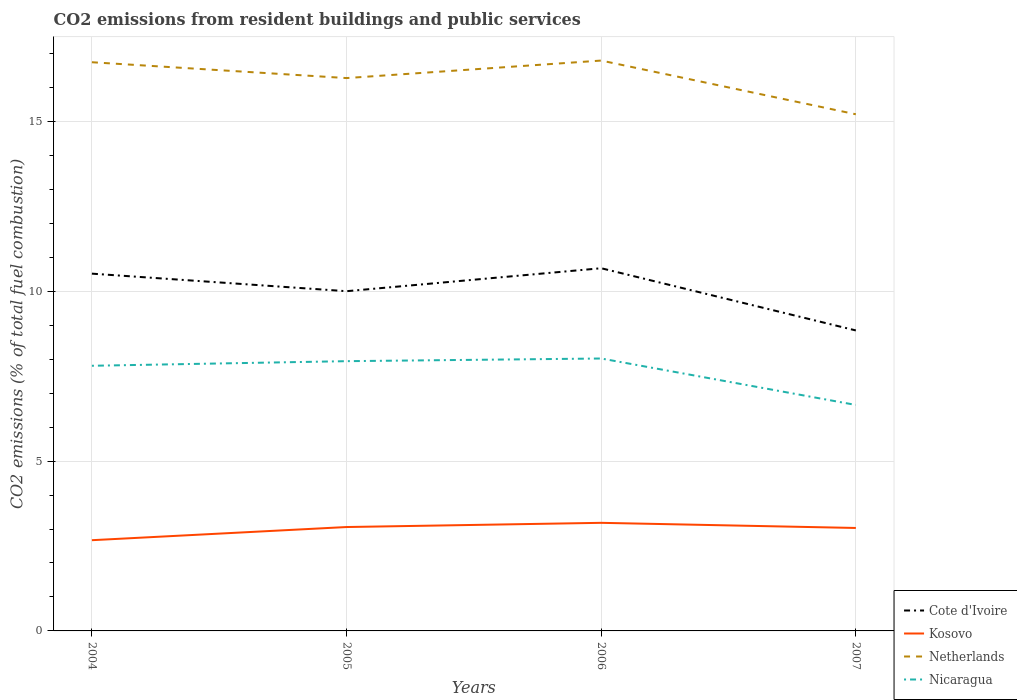Is the number of lines equal to the number of legend labels?
Provide a succinct answer. Yes. Across all years, what is the maximum total CO2 emitted in Kosovo?
Your answer should be very brief. 2.67. What is the total total CO2 emitted in Nicaragua in the graph?
Offer a terse response. -0.14. What is the difference between the highest and the second highest total CO2 emitted in Nicaragua?
Make the answer very short. 1.37. Is the total CO2 emitted in Netherlands strictly greater than the total CO2 emitted in Cote d'Ivoire over the years?
Your answer should be very brief. No. How many lines are there?
Ensure brevity in your answer.  4. What is the difference between two consecutive major ticks on the Y-axis?
Offer a very short reply. 5. Are the values on the major ticks of Y-axis written in scientific E-notation?
Your answer should be very brief. No. How are the legend labels stacked?
Make the answer very short. Vertical. What is the title of the graph?
Offer a very short reply. CO2 emissions from resident buildings and public services. Does "Madagascar" appear as one of the legend labels in the graph?
Offer a terse response. No. What is the label or title of the X-axis?
Your answer should be very brief. Years. What is the label or title of the Y-axis?
Make the answer very short. CO2 emissions (% of total fuel combustion). What is the CO2 emissions (% of total fuel combustion) in Cote d'Ivoire in 2004?
Ensure brevity in your answer.  10.52. What is the CO2 emissions (% of total fuel combustion) in Kosovo in 2004?
Your answer should be very brief. 2.67. What is the CO2 emissions (% of total fuel combustion) of Netherlands in 2004?
Your answer should be very brief. 16.74. What is the CO2 emissions (% of total fuel combustion) in Nicaragua in 2004?
Ensure brevity in your answer.  7.8. What is the CO2 emissions (% of total fuel combustion) in Cote d'Ivoire in 2005?
Offer a terse response. 10. What is the CO2 emissions (% of total fuel combustion) in Kosovo in 2005?
Provide a short and direct response. 3.06. What is the CO2 emissions (% of total fuel combustion) of Netherlands in 2005?
Your response must be concise. 16.27. What is the CO2 emissions (% of total fuel combustion) of Nicaragua in 2005?
Give a very brief answer. 7.94. What is the CO2 emissions (% of total fuel combustion) in Cote d'Ivoire in 2006?
Offer a very short reply. 10.68. What is the CO2 emissions (% of total fuel combustion) of Kosovo in 2006?
Give a very brief answer. 3.18. What is the CO2 emissions (% of total fuel combustion) in Netherlands in 2006?
Provide a succinct answer. 16.79. What is the CO2 emissions (% of total fuel combustion) of Nicaragua in 2006?
Offer a terse response. 8.02. What is the CO2 emissions (% of total fuel combustion) of Cote d'Ivoire in 2007?
Your answer should be compact. 8.84. What is the CO2 emissions (% of total fuel combustion) in Kosovo in 2007?
Make the answer very short. 3.03. What is the CO2 emissions (% of total fuel combustion) in Netherlands in 2007?
Provide a short and direct response. 15.21. What is the CO2 emissions (% of total fuel combustion) in Nicaragua in 2007?
Give a very brief answer. 6.65. Across all years, what is the maximum CO2 emissions (% of total fuel combustion) in Cote d'Ivoire?
Offer a very short reply. 10.68. Across all years, what is the maximum CO2 emissions (% of total fuel combustion) of Kosovo?
Give a very brief answer. 3.18. Across all years, what is the maximum CO2 emissions (% of total fuel combustion) in Netherlands?
Offer a very short reply. 16.79. Across all years, what is the maximum CO2 emissions (% of total fuel combustion) of Nicaragua?
Ensure brevity in your answer.  8.02. Across all years, what is the minimum CO2 emissions (% of total fuel combustion) of Cote d'Ivoire?
Provide a succinct answer. 8.84. Across all years, what is the minimum CO2 emissions (% of total fuel combustion) of Kosovo?
Your response must be concise. 2.67. Across all years, what is the minimum CO2 emissions (% of total fuel combustion) in Netherlands?
Offer a very short reply. 15.21. Across all years, what is the minimum CO2 emissions (% of total fuel combustion) of Nicaragua?
Offer a very short reply. 6.65. What is the total CO2 emissions (% of total fuel combustion) in Cote d'Ivoire in the graph?
Your answer should be very brief. 40.04. What is the total CO2 emissions (% of total fuel combustion) in Kosovo in the graph?
Offer a terse response. 11.94. What is the total CO2 emissions (% of total fuel combustion) in Netherlands in the graph?
Offer a terse response. 65.01. What is the total CO2 emissions (% of total fuel combustion) of Nicaragua in the graph?
Keep it short and to the point. 30.42. What is the difference between the CO2 emissions (% of total fuel combustion) of Cote d'Ivoire in 2004 and that in 2005?
Keep it short and to the point. 0.52. What is the difference between the CO2 emissions (% of total fuel combustion) in Kosovo in 2004 and that in 2005?
Give a very brief answer. -0.39. What is the difference between the CO2 emissions (% of total fuel combustion) in Netherlands in 2004 and that in 2005?
Make the answer very short. 0.47. What is the difference between the CO2 emissions (% of total fuel combustion) in Nicaragua in 2004 and that in 2005?
Ensure brevity in your answer.  -0.14. What is the difference between the CO2 emissions (% of total fuel combustion) in Cote d'Ivoire in 2004 and that in 2006?
Make the answer very short. -0.16. What is the difference between the CO2 emissions (% of total fuel combustion) of Kosovo in 2004 and that in 2006?
Provide a succinct answer. -0.51. What is the difference between the CO2 emissions (% of total fuel combustion) of Netherlands in 2004 and that in 2006?
Your response must be concise. -0.05. What is the difference between the CO2 emissions (% of total fuel combustion) in Nicaragua in 2004 and that in 2006?
Your answer should be compact. -0.21. What is the difference between the CO2 emissions (% of total fuel combustion) in Cote d'Ivoire in 2004 and that in 2007?
Offer a terse response. 1.67. What is the difference between the CO2 emissions (% of total fuel combustion) of Kosovo in 2004 and that in 2007?
Provide a short and direct response. -0.36. What is the difference between the CO2 emissions (% of total fuel combustion) of Netherlands in 2004 and that in 2007?
Provide a succinct answer. 1.53. What is the difference between the CO2 emissions (% of total fuel combustion) of Nicaragua in 2004 and that in 2007?
Provide a short and direct response. 1.15. What is the difference between the CO2 emissions (% of total fuel combustion) of Cote d'Ivoire in 2005 and that in 2006?
Offer a very short reply. -0.68. What is the difference between the CO2 emissions (% of total fuel combustion) in Kosovo in 2005 and that in 2006?
Give a very brief answer. -0.12. What is the difference between the CO2 emissions (% of total fuel combustion) in Netherlands in 2005 and that in 2006?
Provide a succinct answer. -0.52. What is the difference between the CO2 emissions (% of total fuel combustion) in Nicaragua in 2005 and that in 2006?
Keep it short and to the point. -0.08. What is the difference between the CO2 emissions (% of total fuel combustion) of Cote d'Ivoire in 2005 and that in 2007?
Offer a very short reply. 1.16. What is the difference between the CO2 emissions (% of total fuel combustion) in Kosovo in 2005 and that in 2007?
Keep it short and to the point. 0.03. What is the difference between the CO2 emissions (% of total fuel combustion) in Netherlands in 2005 and that in 2007?
Make the answer very short. 1.07. What is the difference between the CO2 emissions (% of total fuel combustion) of Nicaragua in 2005 and that in 2007?
Your answer should be compact. 1.29. What is the difference between the CO2 emissions (% of total fuel combustion) of Cote d'Ivoire in 2006 and that in 2007?
Offer a terse response. 1.83. What is the difference between the CO2 emissions (% of total fuel combustion) in Kosovo in 2006 and that in 2007?
Offer a very short reply. 0.15. What is the difference between the CO2 emissions (% of total fuel combustion) in Netherlands in 2006 and that in 2007?
Ensure brevity in your answer.  1.58. What is the difference between the CO2 emissions (% of total fuel combustion) of Nicaragua in 2006 and that in 2007?
Make the answer very short. 1.37. What is the difference between the CO2 emissions (% of total fuel combustion) in Cote d'Ivoire in 2004 and the CO2 emissions (% of total fuel combustion) in Kosovo in 2005?
Keep it short and to the point. 7.46. What is the difference between the CO2 emissions (% of total fuel combustion) in Cote d'Ivoire in 2004 and the CO2 emissions (% of total fuel combustion) in Netherlands in 2005?
Your answer should be compact. -5.76. What is the difference between the CO2 emissions (% of total fuel combustion) of Cote d'Ivoire in 2004 and the CO2 emissions (% of total fuel combustion) of Nicaragua in 2005?
Your answer should be very brief. 2.58. What is the difference between the CO2 emissions (% of total fuel combustion) of Kosovo in 2004 and the CO2 emissions (% of total fuel combustion) of Netherlands in 2005?
Ensure brevity in your answer.  -13.6. What is the difference between the CO2 emissions (% of total fuel combustion) of Kosovo in 2004 and the CO2 emissions (% of total fuel combustion) of Nicaragua in 2005?
Provide a short and direct response. -5.27. What is the difference between the CO2 emissions (% of total fuel combustion) in Netherlands in 2004 and the CO2 emissions (% of total fuel combustion) in Nicaragua in 2005?
Your answer should be compact. 8.8. What is the difference between the CO2 emissions (% of total fuel combustion) of Cote d'Ivoire in 2004 and the CO2 emissions (% of total fuel combustion) of Kosovo in 2006?
Ensure brevity in your answer.  7.33. What is the difference between the CO2 emissions (% of total fuel combustion) in Cote d'Ivoire in 2004 and the CO2 emissions (% of total fuel combustion) in Netherlands in 2006?
Make the answer very short. -6.27. What is the difference between the CO2 emissions (% of total fuel combustion) of Cote d'Ivoire in 2004 and the CO2 emissions (% of total fuel combustion) of Nicaragua in 2006?
Give a very brief answer. 2.5. What is the difference between the CO2 emissions (% of total fuel combustion) in Kosovo in 2004 and the CO2 emissions (% of total fuel combustion) in Netherlands in 2006?
Ensure brevity in your answer.  -14.12. What is the difference between the CO2 emissions (% of total fuel combustion) of Kosovo in 2004 and the CO2 emissions (% of total fuel combustion) of Nicaragua in 2006?
Offer a terse response. -5.35. What is the difference between the CO2 emissions (% of total fuel combustion) of Netherlands in 2004 and the CO2 emissions (% of total fuel combustion) of Nicaragua in 2006?
Offer a very short reply. 8.72. What is the difference between the CO2 emissions (% of total fuel combustion) of Cote d'Ivoire in 2004 and the CO2 emissions (% of total fuel combustion) of Kosovo in 2007?
Offer a terse response. 7.49. What is the difference between the CO2 emissions (% of total fuel combustion) in Cote d'Ivoire in 2004 and the CO2 emissions (% of total fuel combustion) in Netherlands in 2007?
Give a very brief answer. -4.69. What is the difference between the CO2 emissions (% of total fuel combustion) in Cote d'Ivoire in 2004 and the CO2 emissions (% of total fuel combustion) in Nicaragua in 2007?
Your answer should be compact. 3.87. What is the difference between the CO2 emissions (% of total fuel combustion) in Kosovo in 2004 and the CO2 emissions (% of total fuel combustion) in Netherlands in 2007?
Provide a succinct answer. -12.54. What is the difference between the CO2 emissions (% of total fuel combustion) in Kosovo in 2004 and the CO2 emissions (% of total fuel combustion) in Nicaragua in 2007?
Offer a very short reply. -3.98. What is the difference between the CO2 emissions (% of total fuel combustion) in Netherlands in 2004 and the CO2 emissions (% of total fuel combustion) in Nicaragua in 2007?
Ensure brevity in your answer.  10.09. What is the difference between the CO2 emissions (% of total fuel combustion) of Cote d'Ivoire in 2005 and the CO2 emissions (% of total fuel combustion) of Kosovo in 2006?
Offer a terse response. 6.82. What is the difference between the CO2 emissions (% of total fuel combustion) of Cote d'Ivoire in 2005 and the CO2 emissions (% of total fuel combustion) of Netherlands in 2006?
Your answer should be compact. -6.79. What is the difference between the CO2 emissions (% of total fuel combustion) of Cote d'Ivoire in 2005 and the CO2 emissions (% of total fuel combustion) of Nicaragua in 2006?
Offer a very short reply. 1.98. What is the difference between the CO2 emissions (% of total fuel combustion) of Kosovo in 2005 and the CO2 emissions (% of total fuel combustion) of Netherlands in 2006?
Make the answer very short. -13.73. What is the difference between the CO2 emissions (% of total fuel combustion) in Kosovo in 2005 and the CO2 emissions (% of total fuel combustion) in Nicaragua in 2006?
Make the answer very short. -4.96. What is the difference between the CO2 emissions (% of total fuel combustion) of Netherlands in 2005 and the CO2 emissions (% of total fuel combustion) of Nicaragua in 2006?
Your response must be concise. 8.25. What is the difference between the CO2 emissions (% of total fuel combustion) of Cote d'Ivoire in 2005 and the CO2 emissions (% of total fuel combustion) of Kosovo in 2007?
Provide a succinct answer. 6.97. What is the difference between the CO2 emissions (% of total fuel combustion) of Cote d'Ivoire in 2005 and the CO2 emissions (% of total fuel combustion) of Netherlands in 2007?
Offer a terse response. -5.21. What is the difference between the CO2 emissions (% of total fuel combustion) of Cote d'Ivoire in 2005 and the CO2 emissions (% of total fuel combustion) of Nicaragua in 2007?
Offer a terse response. 3.35. What is the difference between the CO2 emissions (% of total fuel combustion) of Kosovo in 2005 and the CO2 emissions (% of total fuel combustion) of Netherlands in 2007?
Give a very brief answer. -12.15. What is the difference between the CO2 emissions (% of total fuel combustion) of Kosovo in 2005 and the CO2 emissions (% of total fuel combustion) of Nicaragua in 2007?
Your answer should be very brief. -3.59. What is the difference between the CO2 emissions (% of total fuel combustion) of Netherlands in 2005 and the CO2 emissions (% of total fuel combustion) of Nicaragua in 2007?
Your answer should be compact. 9.62. What is the difference between the CO2 emissions (% of total fuel combustion) in Cote d'Ivoire in 2006 and the CO2 emissions (% of total fuel combustion) in Kosovo in 2007?
Your answer should be compact. 7.65. What is the difference between the CO2 emissions (% of total fuel combustion) in Cote d'Ivoire in 2006 and the CO2 emissions (% of total fuel combustion) in Netherlands in 2007?
Provide a short and direct response. -4.53. What is the difference between the CO2 emissions (% of total fuel combustion) in Cote d'Ivoire in 2006 and the CO2 emissions (% of total fuel combustion) in Nicaragua in 2007?
Make the answer very short. 4.02. What is the difference between the CO2 emissions (% of total fuel combustion) of Kosovo in 2006 and the CO2 emissions (% of total fuel combustion) of Netherlands in 2007?
Your answer should be compact. -12.03. What is the difference between the CO2 emissions (% of total fuel combustion) in Kosovo in 2006 and the CO2 emissions (% of total fuel combustion) in Nicaragua in 2007?
Ensure brevity in your answer.  -3.47. What is the difference between the CO2 emissions (% of total fuel combustion) of Netherlands in 2006 and the CO2 emissions (% of total fuel combustion) of Nicaragua in 2007?
Make the answer very short. 10.14. What is the average CO2 emissions (% of total fuel combustion) of Cote d'Ivoire per year?
Make the answer very short. 10.01. What is the average CO2 emissions (% of total fuel combustion) in Kosovo per year?
Ensure brevity in your answer.  2.99. What is the average CO2 emissions (% of total fuel combustion) in Netherlands per year?
Your response must be concise. 16.25. What is the average CO2 emissions (% of total fuel combustion) in Nicaragua per year?
Make the answer very short. 7.6. In the year 2004, what is the difference between the CO2 emissions (% of total fuel combustion) in Cote d'Ivoire and CO2 emissions (% of total fuel combustion) in Kosovo?
Provide a succinct answer. 7.85. In the year 2004, what is the difference between the CO2 emissions (% of total fuel combustion) in Cote d'Ivoire and CO2 emissions (% of total fuel combustion) in Netherlands?
Provide a short and direct response. -6.22. In the year 2004, what is the difference between the CO2 emissions (% of total fuel combustion) in Cote d'Ivoire and CO2 emissions (% of total fuel combustion) in Nicaragua?
Keep it short and to the point. 2.71. In the year 2004, what is the difference between the CO2 emissions (% of total fuel combustion) in Kosovo and CO2 emissions (% of total fuel combustion) in Netherlands?
Your answer should be compact. -14.07. In the year 2004, what is the difference between the CO2 emissions (% of total fuel combustion) of Kosovo and CO2 emissions (% of total fuel combustion) of Nicaragua?
Make the answer very short. -5.13. In the year 2004, what is the difference between the CO2 emissions (% of total fuel combustion) of Netherlands and CO2 emissions (% of total fuel combustion) of Nicaragua?
Provide a succinct answer. 8.93. In the year 2005, what is the difference between the CO2 emissions (% of total fuel combustion) in Cote d'Ivoire and CO2 emissions (% of total fuel combustion) in Kosovo?
Your answer should be compact. 6.94. In the year 2005, what is the difference between the CO2 emissions (% of total fuel combustion) in Cote d'Ivoire and CO2 emissions (% of total fuel combustion) in Netherlands?
Your answer should be compact. -6.27. In the year 2005, what is the difference between the CO2 emissions (% of total fuel combustion) of Cote d'Ivoire and CO2 emissions (% of total fuel combustion) of Nicaragua?
Provide a succinct answer. 2.06. In the year 2005, what is the difference between the CO2 emissions (% of total fuel combustion) of Kosovo and CO2 emissions (% of total fuel combustion) of Netherlands?
Your answer should be compact. -13.22. In the year 2005, what is the difference between the CO2 emissions (% of total fuel combustion) in Kosovo and CO2 emissions (% of total fuel combustion) in Nicaragua?
Provide a succinct answer. -4.88. In the year 2005, what is the difference between the CO2 emissions (% of total fuel combustion) of Netherlands and CO2 emissions (% of total fuel combustion) of Nicaragua?
Provide a succinct answer. 8.33. In the year 2006, what is the difference between the CO2 emissions (% of total fuel combustion) of Cote d'Ivoire and CO2 emissions (% of total fuel combustion) of Kosovo?
Your response must be concise. 7.49. In the year 2006, what is the difference between the CO2 emissions (% of total fuel combustion) in Cote d'Ivoire and CO2 emissions (% of total fuel combustion) in Netherlands?
Your answer should be compact. -6.11. In the year 2006, what is the difference between the CO2 emissions (% of total fuel combustion) in Cote d'Ivoire and CO2 emissions (% of total fuel combustion) in Nicaragua?
Offer a very short reply. 2.66. In the year 2006, what is the difference between the CO2 emissions (% of total fuel combustion) of Kosovo and CO2 emissions (% of total fuel combustion) of Netherlands?
Make the answer very short. -13.61. In the year 2006, what is the difference between the CO2 emissions (% of total fuel combustion) of Kosovo and CO2 emissions (% of total fuel combustion) of Nicaragua?
Offer a very short reply. -4.84. In the year 2006, what is the difference between the CO2 emissions (% of total fuel combustion) in Netherlands and CO2 emissions (% of total fuel combustion) in Nicaragua?
Give a very brief answer. 8.77. In the year 2007, what is the difference between the CO2 emissions (% of total fuel combustion) of Cote d'Ivoire and CO2 emissions (% of total fuel combustion) of Kosovo?
Make the answer very short. 5.81. In the year 2007, what is the difference between the CO2 emissions (% of total fuel combustion) in Cote d'Ivoire and CO2 emissions (% of total fuel combustion) in Netherlands?
Your answer should be very brief. -6.36. In the year 2007, what is the difference between the CO2 emissions (% of total fuel combustion) in Cote d'Ivoire and CO2 emissions (% of total fuel combustion) in Nicaragua?
Make the answer very short. 2.19. In the year 2007, what is the difference between the CO2 emissions (% of total fuel combustion) in Kosovo and CO2 emissions (% of total fuel combustion) in Netherlands?
Keep it short and to the point. -12.18. In the year 2007, what is the difference between the CO2 emissions (% of total fuel combustion) in Kosovo and CO2 emissions (% of total fuel combustion) in Nicaragua?
Your answer should be compact. -3.62. In the year 2007, what is the difference between the CO2 emissions (% of total fuel combustion) in Netherlands and CO2 emissions (% of total fuel combustion) in Nicaragua?
Give a very brief answer. 8.56. What is the ratio of the CO2 emissions (% of total fuel combustion) in Cote d'Ivoire in 2004 to that in 2005?
Offer a very short reply. 1.05. What is the ratio of the CO2 emissions (% of total fuel combustion) of Kosovo in 2004 to that in 2005?
Your response must be concise. 0.87. What is the ratio of the CO2 emissions (% of total fuel combustion) in Netherlands in 2004 to that in 2005?
Offer a very short reply. 1.03. What is the ratio of the CO2 emissions (% of total fuel combustion) in Nicaragua in 2004 to that in 2005?
Your response must be concise. 0.98. What is the ratio of the CO2 emissions (% of total fuel combustion) of Cote d'Ivoire in 2004 to that in 2006?
Offer a terse response. 0.99. What is the ratio of the CO2 emissions (% of total fuel combustion) of Kosovo in 2004 to that in 2006?
Provide a short and direct response. 0.84. What is the ratio of the CO2 emissions (% of total fuel combustion) in Nicaragua in 2004 to that in 2006?
Offer a terse response. 0.97. What is the ratio of the CO2 emissions (% of total fuel combustion) in Cote d'Ivoire in 2004 to that in 2007?
Offer a terse response. 1.19. What is the ratio of the CO2 emissions (% of total fuel combustion) in Kosovo in 2004 to that in 2007?
Offer a terse response. 0.88. What is the ratio of the CO2 emissions (% of total fuel combustion) of Netherlands in 2004 to that in 2007?
Ensure brevity in your answer.  1.1. What is the ratio of the CO2 emissions (% of total fuel combustion) of Nicaragua in 2004 to that in 2007?
Provide a succinct answer. 1.17. What is the ratio of the CO2 emissions (% of total fuel combustion) in Cote d'Ivoire in 2005 to that in 2006?
Your answer should be very brief. 0.94. What is the ratio of the CO2 emissions (% of total fuel combustion) in Kosovo in 2005 to that in 2006?
Provide a succinct answer. 0.96. What is the ratio of the CO2 emissions (% of total fuel combustion) in Netherlands in 2005 to that in 2006?
Give a very brief answer. 0.97. What is the ratio of the CO2 emissions (% of total fuel combustion) of Nicaragua in 2005 to that in 2006?
Give a very brief answer. 0.99. What is the ratio of the CO2 emissions (% of total fuel combustion) of Cote d'Ivoire in 2005 to that in 2007?
Your answer should be very brief. 1.13. What is the ratio of the CO2 emissions (% of total fuel combustion) of Kosovo in 2005 to that in 2007?
Ensure brevity in your answer.  1.01. What is the ratio of the CO2 emissions (% of total fuel combustion) in Netherlands in 2005 to that in 2007?
Your response must be concise. 1.07. What is the ratio of the CO2 emissions (% of total fuel combustion) of Nicaragua in 2005 to that in 2007?
Ensure brevity in your answer.  1.19. What is the ratio of the CO2 emissions (% of total fuel combustion) in Cote d'Ivoire in 2006 to that in 2007?
Your answer should be very brief. 1.21. What is the ratio of the CO2 emissions (% of total fuel combustion) of Kosovo in 2006 to that in 2007?
Offer a very short reply. 1.05. What is the ratio of the CO2 emissions (% of total fuel combustion) in Netherlands in 2006 to that in 2007?
Make the answer very short. 1.1. What is the ratio of the CO2 emissions (% of total fuel combustion) in Nicaragua in 2006 to that in 2007?
Keep it short and to the point. 1.21. What is the difference between the highest and the second highest CO2 emissions (% of total fuel combustion) of Cote d'Ivoire?
Provide a short and direct response. 0.16. What is the difference between the highest and the second highest CO2 emissions (% of total fuel combustion) in Kosovo?
Offer a very short reply. 0.12. What is the difference between the highest and the second highest CO2 emissions (% of total fuel combustion) in Netherlands?
Your answer should be compact. 0.05. What is the difference between the highest and the second highest CO2 emissions (% of total fuel combustion) in Nicaragua?
Keep it short and to the point. 0.08. What is the difference between the highest and the lowest CO2 emissions (% of total fuel combustion) of Cote d'Ivoire?
Provide a succinct answer. 1.83. What is the difference between the highest and the lowest CO2 emissions (% of total fuel combustion) in Kosovo?
Provide a succinct answer. 0.51. What is the difference between the highest and the lowest CO2 emissions (% of total fuel combustion) in Netherlands?
Make the answer very short. 1.58. What is the difference between the highest and the lowest CO2 emissions (% of total fuel combustion) of Nicaragua?
Provide a succinct answer. 1.37. 